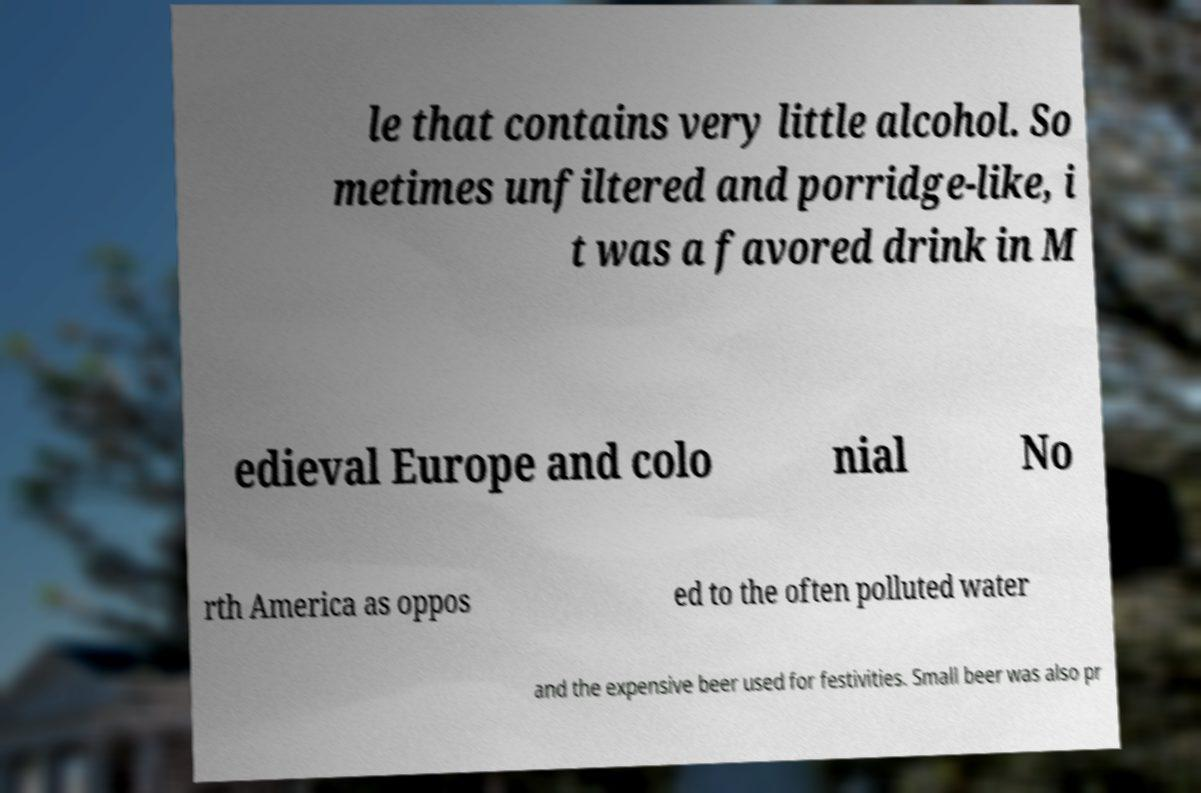What messages or text are displayed in this image? I need them in a readable, typed format. le that contains very little alcohol. So metimes unfiltered and porridge-like, i t was a favored drink in M edieval Europe and colo nial No rth America as oppos ed to the often polluted water and the expensive beer used for festivities. Small beer was also pr 